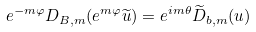<formula> <loc_0><loc_0><loc_500><loc_500>e ^ { - m \varphi } D _ { B , m } ( e ^ { m \varphi } \widetilde { u } ) = e ^ { i m \theta } \widetilde { D } _ { b , m } ( u )</formula> 